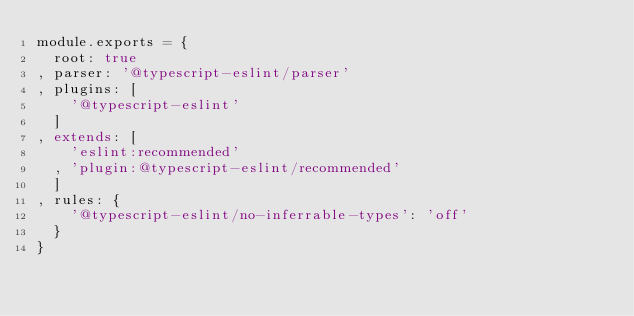<code> <loc_0><loc_0><loc_500><loc_500><_JavaScript_>module.exports = {
  root: true
, parser: '@typescript-eslint/parser'
, plugins: [
    '@typescript-eslint'
  ]
, extends: [
    'eslint:recommended'
  , 'plugin:@typescript-eslint/recommended'
  ]
, rules: {
    '@typescript-eslint/no-inferrable-types': 'off'
  }
}
</code> 